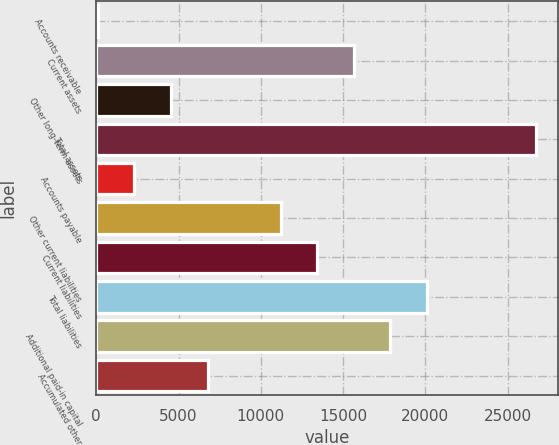<chart> <loc_0><loc_0><loc_500><loc_500><bar_chart><fcel>Accounts receivable<fcel>Current assets<fcel>Other long-term assets<fcel>Total assets<fcel>Accounts payable<fcel>Other current liabilities<fcel>Current liabilities<fcel>Total liabilities<fcel>Additional paid-in capital<fcel>Accumulated other<nl><fcel>102<fcel>15639.9<fcel>4541.4<fcel>26738.4<fcel>2321.7<fcel>11200.5<fcel>13420.2<fcel>20079.3<fcel>17859.6<fcel>6761.1<nl></chart> 